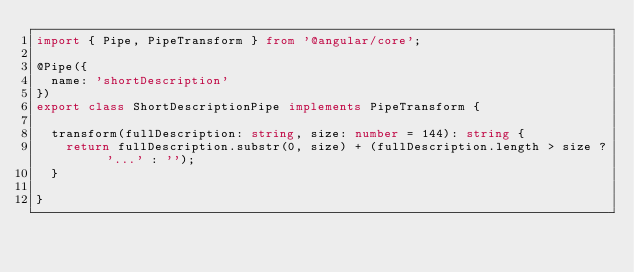<code> <loc_0><loc_0><loc_500><loc_500><_TypeScript_>import { Pipe, PipeTransform } from '@angular/core';

@Pipe({
  name: 'shortDescription'
})
export class ShortDescriptionPipe implements PipeTransform {

  transform(fullDescription: string, size: number = 144): string {
    return fullDescription.substr(0, size) + (fullDescription.length > size ? '...' : '');
  }

}
</code> 